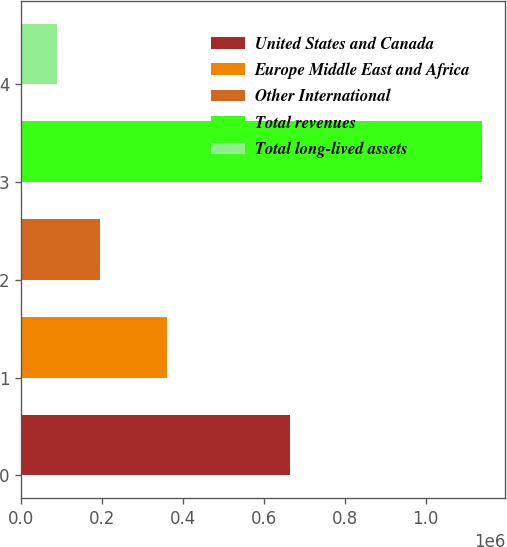Convert chart. <chart><loc_0><loc_0><loc_500><loc_500><bar_chart><fcel>United States and Canada<fcel>Europe Middle East and Africa<fcel>Other International<fcel>Total revenues<fcel>Total long-lived assets<nl><fcel>663832<fcel>360791<fcel>195182<fcel>1.1398e+06<fcel>90224<nl></chart> 